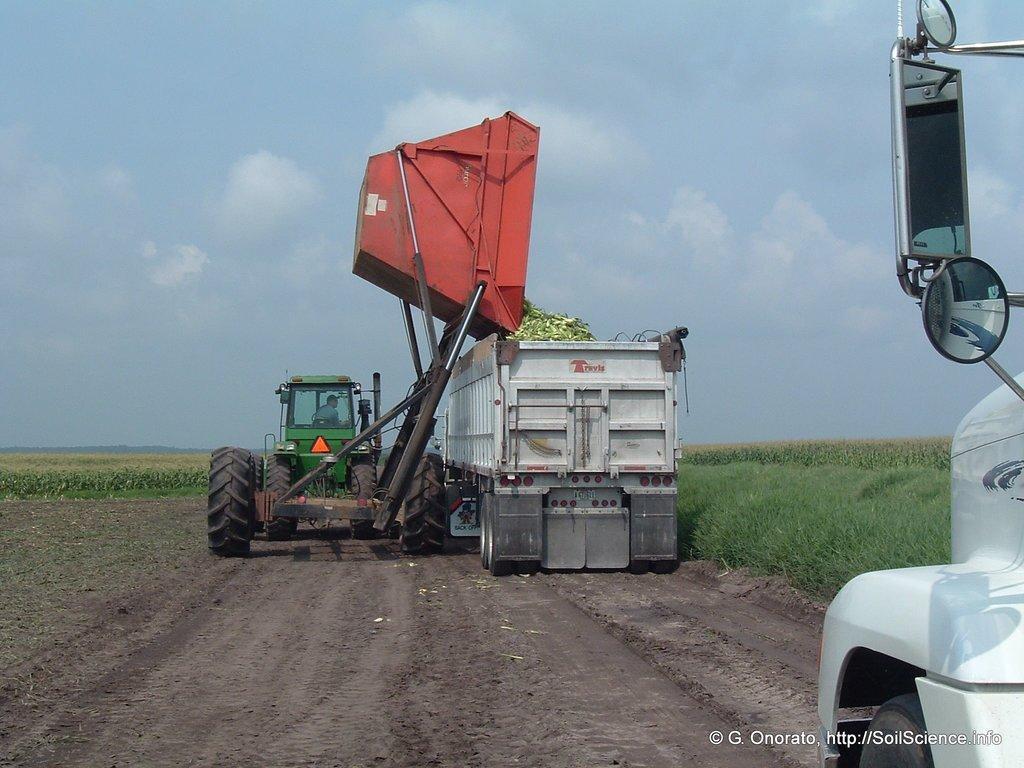In one or two sentences, can you explain what this image depicts? This image is taken outdoors. At the bottom of the image there is a ground with grass and fields on it. On the right side of the image there is a vehicle on the ground. In the middle of the image there is a harvester and a truck on the ground. At the top of the image there is a sky with clouds. 